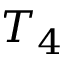<formula> <loc_0><loc_0><loc_500><loc_500>T _ { 4 }</formula> 